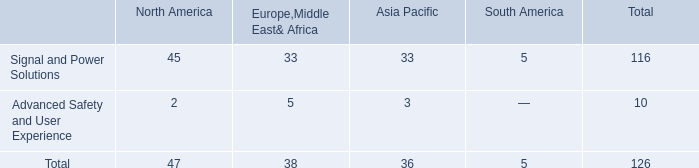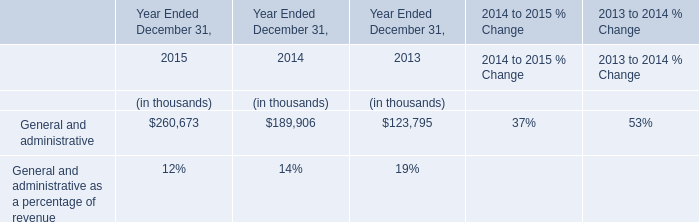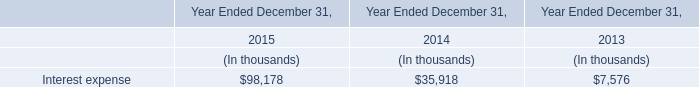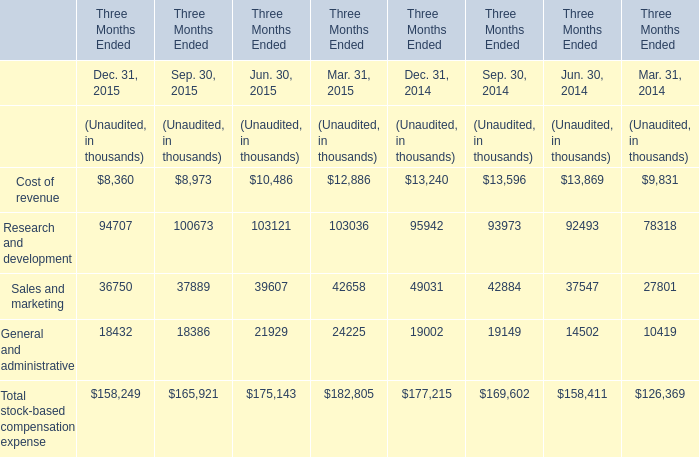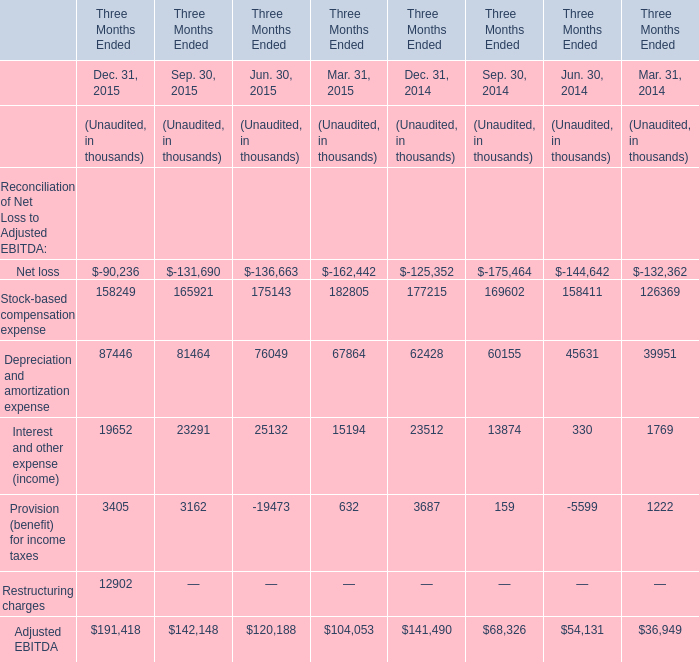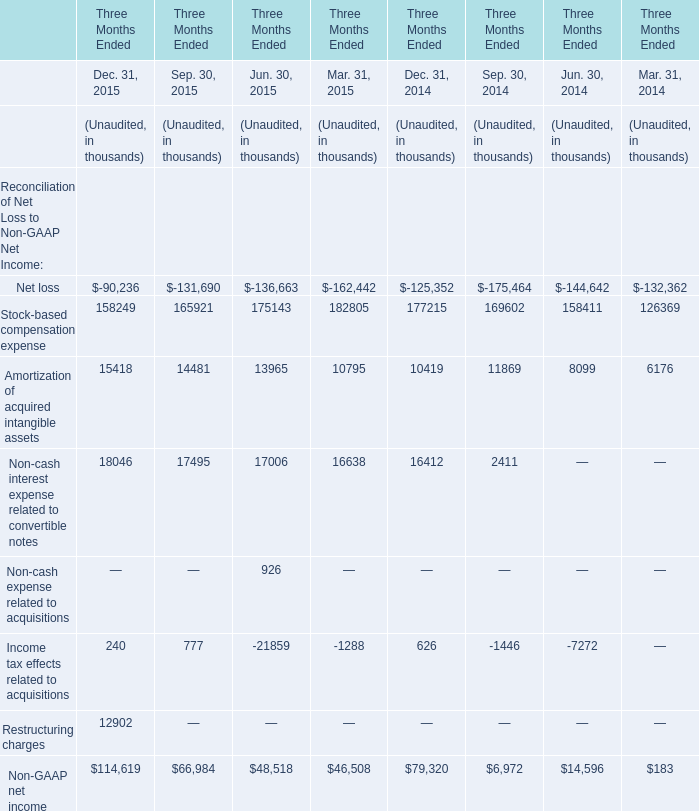Which year is Depreciation and amortization expense the highest? 
Answer: Dec. 31, 2015. 